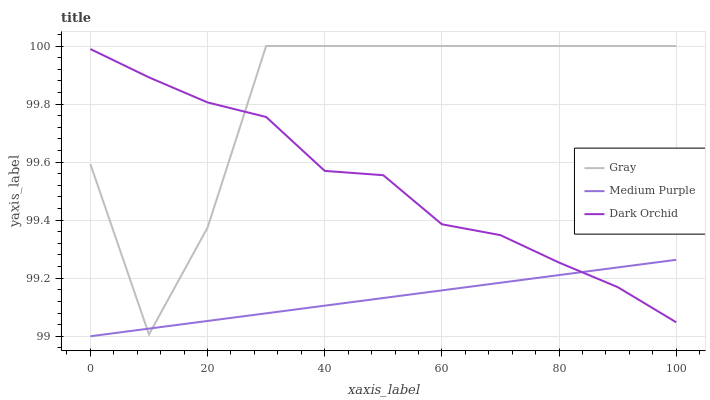Does Medium Purple have the minimum area under the curve?
Answer yes or no. Yes. Does Gray have the maximum area under the curve?
Answer yes or no. Yes. Does Dark Orchid have the minimum area under the curve?
Answer yes or no. No. Does Dark Orchid have the maximum area under the curve?
Answer yes or no. No. Is Medium Purple the smoothest?
Answer yes or no. Yes. Is Gray the roughest?
Answer yes or no. Yes. Is Dark Orchid the smoothest?
Answer yes or no. No. Is Dark Orchid the roughest?
Answer yes or no. No. Does Gray have the lowest value?
Answer yes or no. No. Does Gray have the highest value?
Answer yes or no. Yes. Does Dark Orchid have the highest value?
Answer yes or no. No. Does Gray intersect Dark Orchid?
Answer yes or no. Yes. Is Gray less than Dark Orchid?
Answer yes or no. No. Is Gray greater than Dark Orchid?
Answer yes or no. No. 